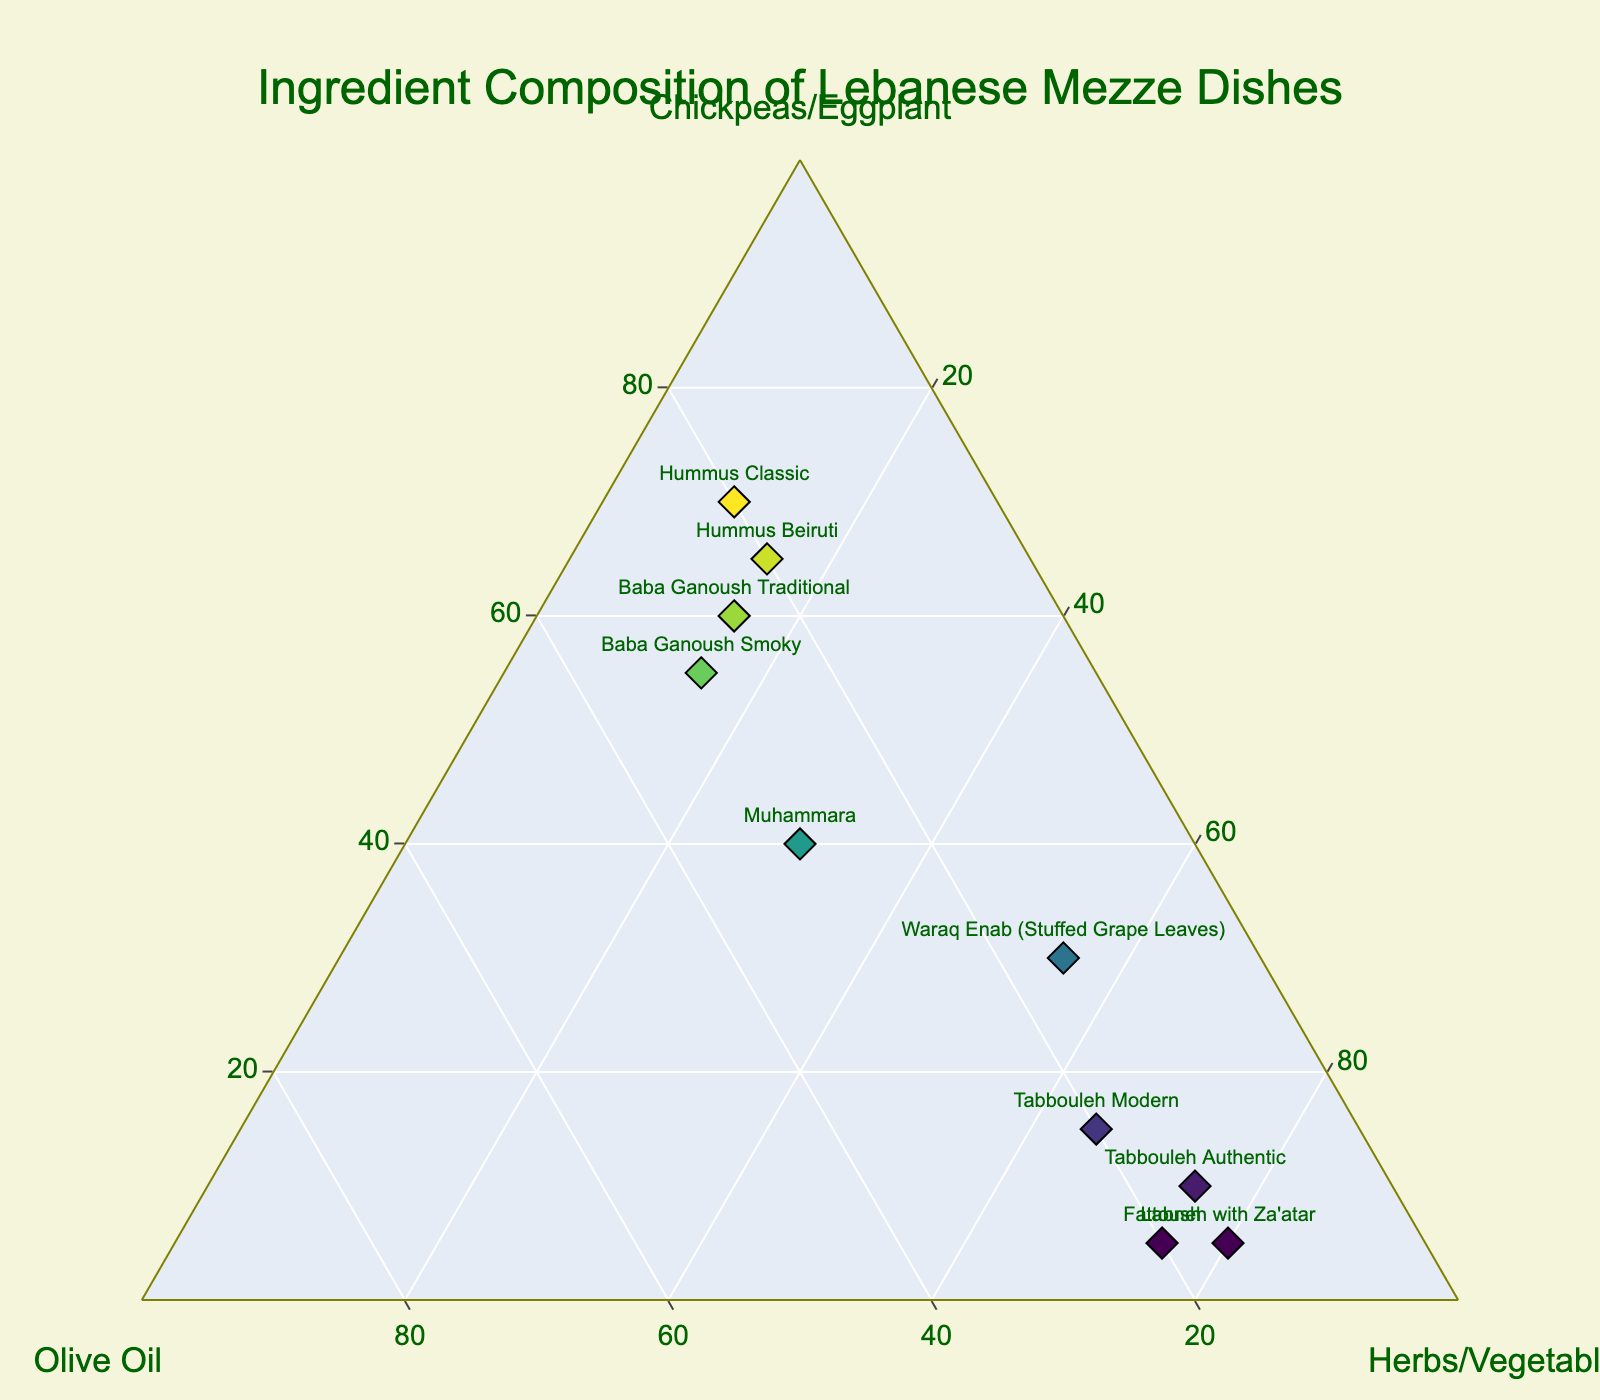What's the title of the figure? The title is at the top of the figure and reads "Ingredient Composition of Lebanese Mezze Dishes".
Answer: Ingredient Composition of Lebanese Mezze Dishes What are the three main ingredients represented in the ternary plot? The ternary plot uses three axes which are labeled Chickpeas/Eggplant, Olive Oil, and Herbs/Vegetables.
Answer: Chickpeas/Eggplant, Olive Oil, Herbs/Vegetables How many dishes are represented in the figure? Count the labels on the data points in the figure; each label corresponds to one dish. There are 10 labels.
Answer: 10 Which dish has the highest percentage of chickpeas/eggplant? Look for the point closest to the Chickpeas/Eggplant corner of the ternary plot. "Hummus Classic" is at the point closest to that corner with 70%.
Answer: Hummus Classic Between "Baba Ganoush Traditional" and "Baba Ganoush Smoky", which dish has a higher percentage of olive oil? Compare their positions along the Olive Oil axis. "Baba Ganoush Smoky" has a higher value at 30% compared to "Baba Ganoush Traditional" at 25%.
Answer: Baba Ganoush Smoky What's the average percentage of herbs/vegetables in Hummus Beiruti and Tabbouleh Modern? Add the herbs/vegetables percentages for both dishes (15% + 65%) and divide by 2. (15 + 65) / 2 = 40%.
Answer: 40% Which dish is positioned closest to having an equal balance of all three ingredients? The dish closest to the center of the ternary plot has all three components in somewhat equal quantities. "Muhammara" is closest to the center with 40% Chickpeas/Eggplant, 30% Olive Oil, and 30% Herbs/Vegetables.
Answer: Muhammara How does the percentage of chickpeas/eggplant in "Waraq Enab" compare to "Tabbouleh Modern"? Compare their percentages. "Waraq Enab" has 30% while "Tabbouleh Modern" has 15%. Waraq Enab has a higher percentage of chickpeas/eggplant.
Answer: Waraq Enab If you combine the percentages of olive oil and herbs/vegetables in "Hummus Classic", what is the total? Add the percentage values for olive oil and herbs/vegetables in Hummus Classic (20% + 10%). 20 + 10 = 30%.
Answer: 30% Which dish has the lowest percentage of chickpeas/eggplant? Look for the dish that is located farthest from the Chickpeas/Eggplant corner. "Labneh with Za'atar" has the lowest percentage at 5%.
Answer: Labneh with Za'atar 